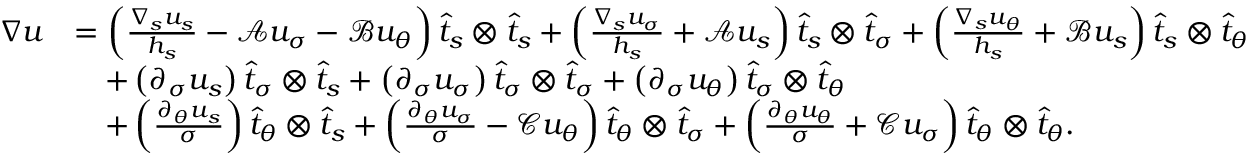Convert formula to latex. <formula><loc_0><loc_0><loc_500><loc_500>\begin{array} { r l } { \nabla u } & { = \left ( \frac { \nabla _ { s } u _ { s } } { h _ { s } } - \mathcal { A } u _ { \sigma } - \mathcal { B } u _ { \theta } \right ) \widehat { t } _ { s } \otimes \widehat { t } _ { s } + \left ( \frac { \nabla _ { s } u _ { \sigma } } { h _ { s } } + \mathcal { A } u _ { s } \right ) \widehat { t } _ { s } \otimes \widehat { t } _ { \sigma } + \left ( \frac { \nabla _ { s } u _ { \theta } } { h _ { s } } + \mathcal { B } u _ { s } \right ) \widehat { t } _ { s } \otimes \widehat { t } _ { \theta } } \\ & { \quad + \left ( \partial _ { \sigma } u _ { s } \right ) \widehat { t } _ { \sigma } \otimes \widehat { t } _ { s } + \left ( \partial _ { \sigma } u _ { \sigma } \right ) \widehat { t } _ { \sigma } \otimes \widehat { t } _ { \sigma } + \left ( \partial _ { \sigma } u _ { \theta } \right ) \widehat { t } _ { \sigma } \otimes \widehat { t } _ { \theta } } \\ & { \quad + \left ( \frac { \partial _ { \theta } u _ { s } } { \sigma } \right ) \widehat { t } _ { \theta } \otimes \widehat { t } _ { s } + \left ( \frac { \partial _ { \theta } u _ { \sigma } } { \sigma } - \mathcal { C } u _ { \theta } \right ) \widehat { t } _ { \theta } \otimes \widehat { t } _ { \sigma } + \left ( \frac { \partial _ { \theta } u _ { \theta } } { \sigma } + \mathcal { C } u _ { \sigma } \right ) \widehat { t } _ { \theta } \otimes \widehat { t } _ { \theta } . } \end{array}</formula> 